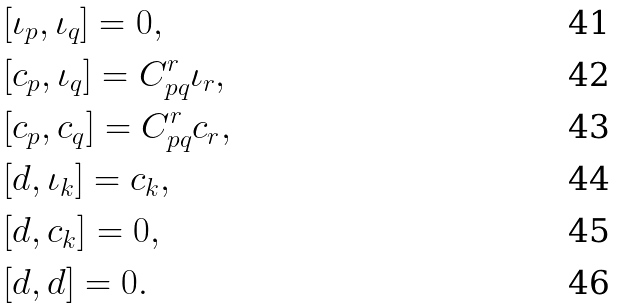Convert formula to latex. <formula><loc_0><loc_0><loc_500><loc_500>& [ \iota _ { p } , \iota _ { q } ] = 0 , \\ & [ \L c _ { p } , \iota _ { q } ] = C ^ { r } _ { p q } \iota _ { r } , \\ & [ \L c _ { p } , \L c _ { q } ] = C ^ { r } _ { p q } \L c _ { r } , \\ & [ d , \iota _ { k } ] = \L c _ { k } , \\ & [ d , \L c _ { k } ] = 0 , \\ & [ d , d ] = 0 .</formula> 